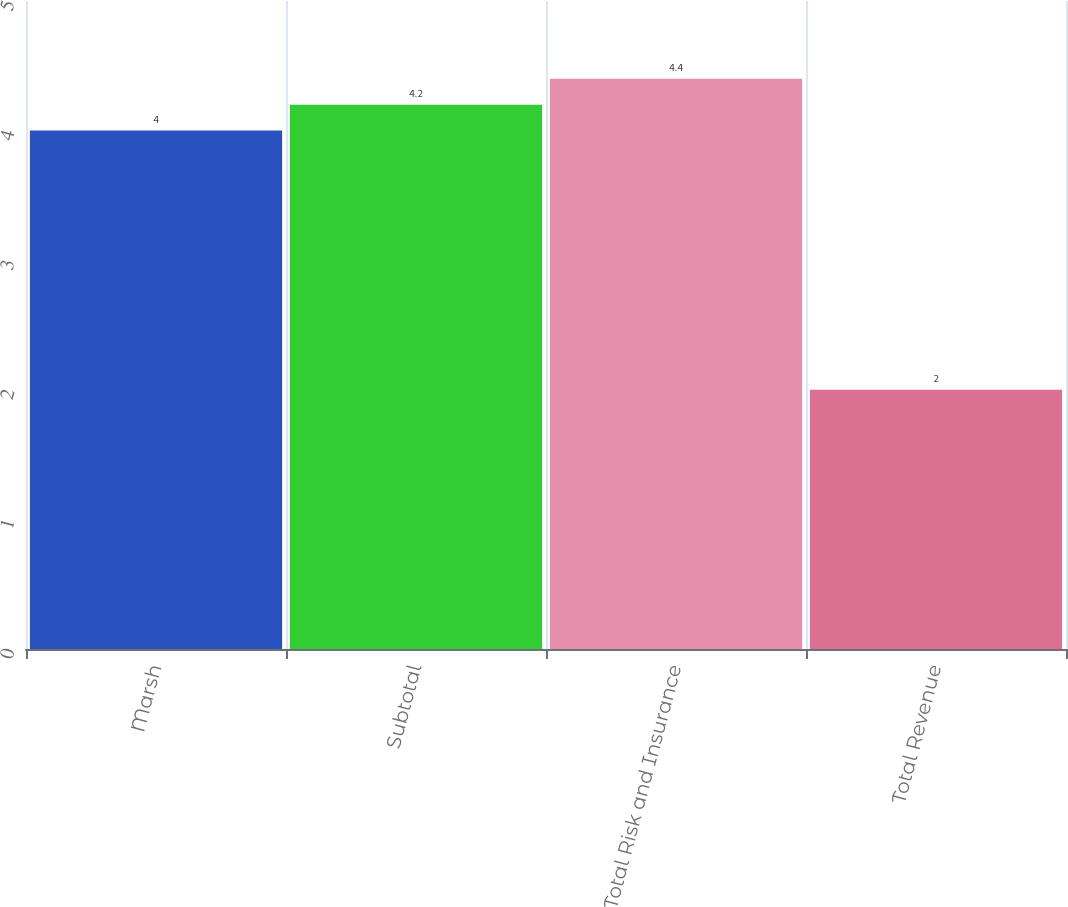Convert chart. <chart><loc_0><loc_0><loc_500><loc_500><bar_chart><fcel>Marsh<fcel>Subtotal<fcel>Total Risk and Insurance<fcel>Total Revenue<nl><fcel>4<fcel>4.2<fcel>4.4<fcel>2<nl></chart> 